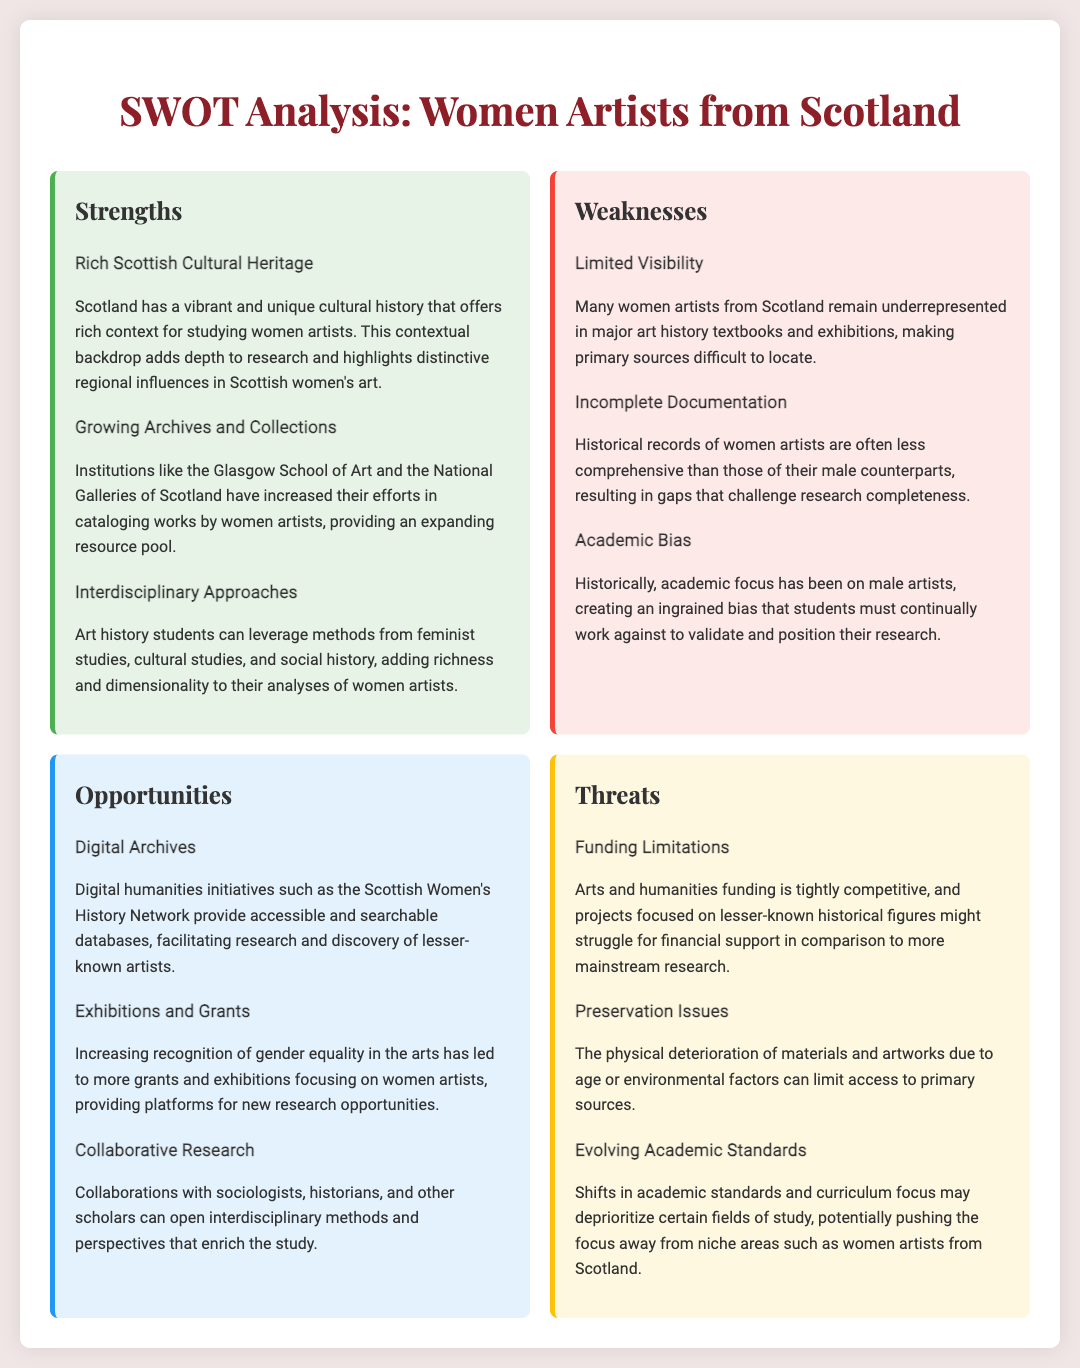What is one strength of studying women artists from Scotland? The document states that Scotland has a vibrant and unique cultural history that offers rich context for studying women artists.
Answer: Rich Scottish Cultural Heritage What institution is mentioned as cataloging works by women artists? The Glasgow School of Art is highlighted as one of the institutions increasing efforts to catalog works by women artists.
Answer: Glasgow School of Art What is a weakness related to historical records of women artists? The document mentions that historical records of women artists are often less comprehensive than those of their male counterparts.
Answer: Incomplete Documentation Which opportunity is associated with digital humanities initiatives? The document discusses the Scottish Women's History Network providing accessible and searchable databases.
Answer: Digital Archives What threat is mentioned regarding funding? The analysis indicates that arts and humanities funding is tightly competitive.
Answer: Funding Limitations How does the document suggest interdisciplinary methods can enrich the study? Collaborative research with sociologists, historians, and other scholars is indicated as a way to open new perspectives.
Answer: Collaborative Research What is one threat to accessing primary sources? The document states that the physical deterioration of materials due to age can limit access.
Answer: Preservation Issues What percentage focus in exhibitions is increasing regarding women artists? The document points out there is an increasing recognition of gender equality in the arts leading to more exhibitions.
Answer: Gender equality 